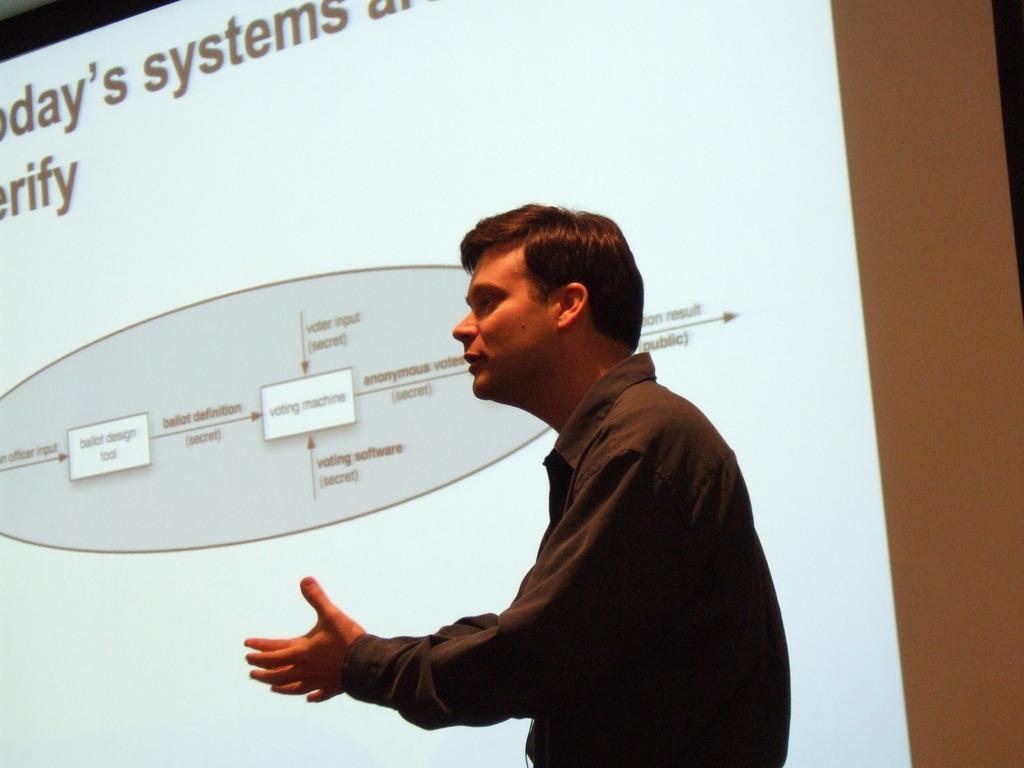Could you give a brief overview of what you see in this image? In the given picture, we can see the projector screen and the person standing. 